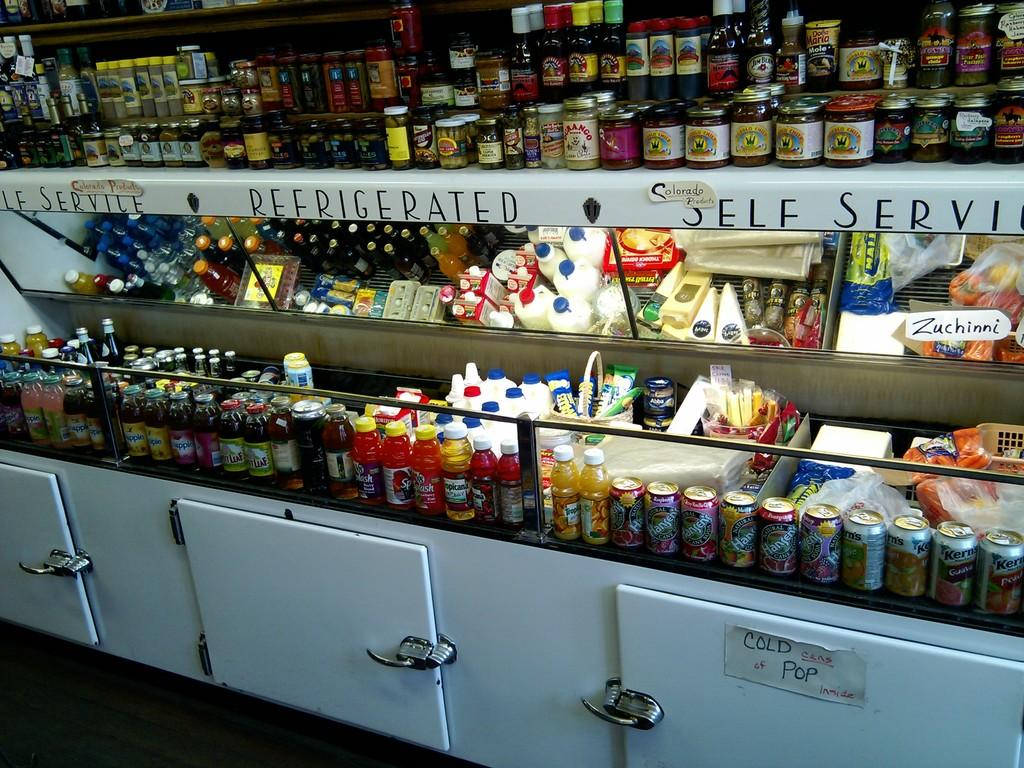<image>
Relay a brief, clear account of the picture shown. A display of drinks indicates that it is "refrigerated and self service." 